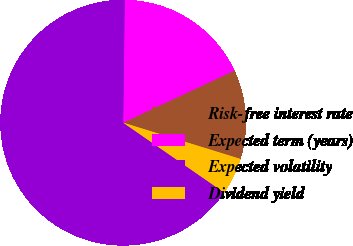Convert chart. <chart><loc_0><loc_0><loc_500><loc_500><pie_chart><fcel>Risk-free interest rate<fcel>Expected term (years)<fcel>Expected volatility<fcel>Dividend yield<nl><fcel>11.75%<fcel>17.82%<fcel>65.57%<fcel>4.86%<nl></chart> 